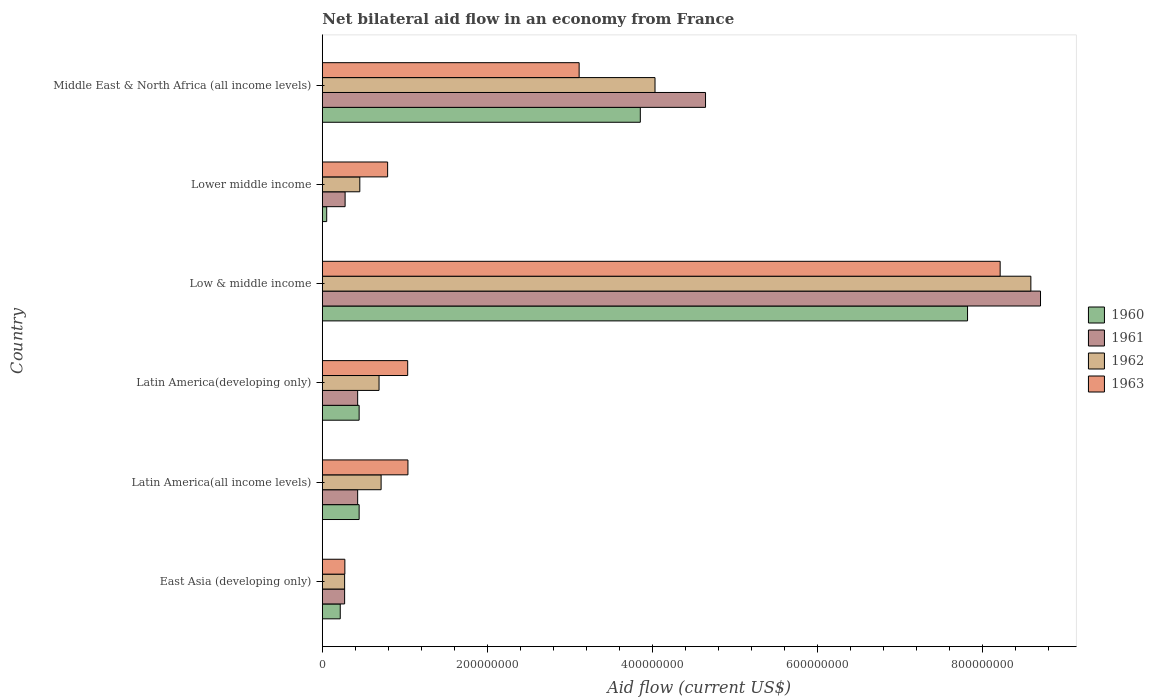Are the number of bars per tick equal to the number of legend labels?
Make the answer very short. Yes. Are the number of bars on each tick of the Y-axis equal?
Ensure brevity in your answer.  Yes. How many bars are there on the 3rd tick from the top?
Offer a terse response. 4. What is the label of the 4th group of bars from the top?
Your answer should be compact. Latin America(developing only). In how many cases, is the number of bars for a given country not equal to the number of legend labels?
Ensure brevity in your answer.  0. What is the net bilateral aid flow in 1961 in Lower middle income?
Keep it short and to the point. 2.76e+07. Across all countries, what is the maximum net bilateral aid flow in 1963?
Keep it short and to the point. 8.21e+08. Across all countries, what is the minimum net bilateral aid flow in 1961?
Make the answer very short. 2.70e+07. In which country was the net bilateral aid flow in 1963 minimum?
Offer a very short reply. East Asia (developing only). What is the total net bilateral aid flow in 1961 in the graph?
Ensure brevity in your answer.  1.47e+09. What is the difference between the net bilateral aid flow in 1961 in East Asia (developing only) and that in Latin America(developing only)?
Your answer should be compact. -1.58e+07. What is the difference between the net bilateral aid flow in 1962 in Middle East & North Africa (all income levels) and the net bilateral aid flow in 1961 in Lower middle income?
Keep it short and to the point. 3.75e+08. What is the average net bilateral aid flow in 1962 per country?
Keep it short and to the point. 2.46e+08. What is the difference between the net bilateral aid flow in 1961 and net bilateral aid flow in 1960 in Middle East & North Africa (all income levels)?
Offer a very short reply. 7.90e+07. What is the ratio of the net bilateral aid flow in 1962 in Latin America(all income levels) to that in Latin America(developing only)?
Provide a short and direct response. 1.04. Is the net bilateral aid flow in 1960 in Lower middle income less than that in Middle East & North Africa (all income levels)?
Ensure brevity in your answer.  Yes. What is the difference between the highest and the second highest net bilateral aid flow in 1962?
Keep it short and to the point. 4.55e+08. What is the difference between the highest and the lowest net bilateral aid flow in 1961?
Offer a terse response. 8.43e+08. Is the sum of the net bilateral aid flow in 1963 in East Asia (developing only) and Latin America(developing only) greater than the maximum net bilateral aid flow in 1961 across all countries?
Ensure brevity in your answer.  No. What does the 2nd bar from the top in Low & middle income represents?
Your answer should be very brief. 1962. What does the 4th bar from the bottom in East Asia (developing only) represents?
Make the answer very short. 1963. How many bars are there?
Make the answer very short. 24. What is the difference between two consecutive major ticks on the X-axis?
Provide a short and direct response. 2.00e+08. Are the values on the major ticks of X-axis written in scientific E-notation?
Your response must be concise. No. Does the graph contain grids?
Your answer should be very brief. No. How are the legend labels stacked?
Provide a short and direct response. Vertical. What is the title of the graph?
Give a very brief answer. Net bilateral aid flow in an economy from France. Does "1967" appear as one of the legend labels in the graph?
Your response must be concise. No. What is the label or title of the X-axis?
Your answer should be compact. Aid flow (current US$). What is the label or title of the Y-axis?
Make the answer very short. Country. What is the Aid flow (current US$) of 1960 in East Asia (developing only)?
Your response must be concise. 2.17e+07. What is the Aid flow (current US$) of 1961 in East Asia (developing only)?
Your response must be concise. 2.70e+07. What is the Aid flow (current US$) in 1962 in East Asia (developing only)?
Your response must be concise. 2.70e+07. What is the Aid flow (current US$) of 1963 in East Asia (developing only)?
Your response must be concise. 2.73e+07. What is the Aid flow (current US$) in 1960 in Latin America(all income levels)?
Keep it short and to the point. 4.46e+07. What is the Aid flow (current US$) of 1961 in Latin America(all income levels)?
Offer a terse response. 4.28e+07. What is the Aid flow (current US$) in 1962 in Latin America(all income levels)?
Provide a succinct answer. 7.12e+07. What is the Aid flow (current US$) of 1963 in Latin America(all income levels)?
Ensure brevity in your answer.  1.04e+08. What is the Aid flow (current US$) in 1960 in Latin America(developing only)?
Give a very brief answer. 4.46e+07. What is the Aid flow (current US$) of 1961 in Latin America(developing only)?
Make the answer very short. 4.28e+07. What is the Aid flow (current US$) of 1962 in Latin America(developing only)?
Your answer should be compact. 6.87e+07. What is the Aid flow (current US$) in 1963 in Latin America(developing only)?
Give a very brief answer. 1.03e+08. What is the Aid flow (current US$) of 1960 in Low & middle income?
Your answer should be compact. 7.82e+08. What is the Aid flow (current US$) in 1961 in Low & middle income?
Offer a terse response. 8.70e+08. What is the Aid flow (current US$) of 1962 in Low & middle income?
Ensure brevity in your answer.  8.58e+08. What is the Aid flow (current US$) in 1963 in Low & middle income?
Provide a succinct answer. 8.21e+08. What is the Aid flow (current US$) of 1960 in Lower middle income?
Keep it short and to the point. 5.30e+06. What is the Aid flow (current US$) in 1961 in Lower middle income?
Your answer should be very brief. 2.76e+07. What is the Aid flow (current US$) in 1962 in Lower middle income?
Offer a very short reply. 4.54e+07. What is the Aid flow (current US$) of 1963 in Lower middle income?
Provide a succinct answer. 7.91e+07. What is the Aid flow (current US$) of 1960 in Middle East & North Africa (all income levels)?
Make the answer very short. 3.85e+08. What is the Aid flow (current US$) of 1961 in Middle East & North Africa (all income levels)?
Make the answer very short. 4.64e+08. What is the Aid flow (current US$) of 1962 in Middle East & North Africa (all income levels)?
Keep it short and to the point. 4.03e+08. What is the Aid flow (current US$) in 1963 in Middle East & North Africa (all income levels)?
Provide a succinct answer. 3.11e+08. Across all countries, what is the maximum Aid flow (current US$) of 1960?
Your answer should be compact. 7.82e+08. Across all countries, what is the maximum Aid flow (current US$) in 1961?
Provide a short and direct response. 8.70e+08. Across all countries, what is the maximum Aid flow (current US$) in 1962?
Offer a very short reply. 8.58e+08. Across all countries, what is the maximum Aid flow (current US$) of 1963?
Provide a succinct answer. 8.21e+08. Across all countries, what is the minimum Aid flow (current US$) of 1960?
Your response must be concise. 5.30e+06. Across all countries, what is the minimum Aid flow (current US$) of 1961?
Your answer should be very brief. 2.70e+07. Across all countries, what is the minimum Aid flow (current US$) in 1962?
Keep it short and to the point. 2.70e+07. Across all countries, what is the minimum Aid flow (current US$) of 1963?
Make the answer very short. 2.73e+07. What is the total Aid flow (current US$) in 1960 in the graph?
Ensure brevity in your answer.  1.28e+09. What is the total Aid flow (current US$) in 1961 in the graph?
Make the answer very short. 1.47e+09. What is the total Aid flow (current US$) of 1962 in the graph?
Make the answer very short. 1.47e+09. What is the total Aid flow (current US$) of 1963 in the graph?
Ensure brevity in your answer.  1.45e+09. What is the difference between the Aid flow (current US$) in 1960 in East Asia (developing only) and that in Latin America(all income levels)?
Offer a terse response. -2.29e+07. What is the difference between the Aid flow (current US$) of 1961 in East Asia (developing only) and that in Latin America(all income levels)?
Provide a short and direct response. -1.58e+07. What is the difference between the Aid flow (current US$) in 1962 in East Asia (developing only) and that in Latin America(all income levels)?
Provide a succinct answer. -4.42e+07. What is the difference between the Aid flow (current US$) of 1963 in East Asia (developing only) and that in Latin America(all income levels)?
Your answer should be very brief. -7.64e+07. What is the difference between the Aid flow (current US$) of 1960 in East Asia (developing only) and that in Latin America(developing only)?
Give a very brief answer. -2.29e+07. What is the difference between the Aid flow (current US$) in 1961 in East Asia (developing only) and that in Latin America(developing only)?
Offer a very short reply. -1.58e+07. What is the difference between the Aid flow (current US$) of 1962 in East Asia (developing only) and that in Latin America(developing only)?
Offer a very short reply. -4.17e+07. What is the difference between the Aid flow (current US$) of 1963 in East Asia (developing only) and that in Latin America(developing only)?
Provide a succinct answer. -7.61e+07. What is the difference between the Aid flow (current US$) of 1960 in East Asia (developing only) and that in Low & middle income?
Give a very brief answer. -7.60e+08. What is the difference between the Aid flow (current US$) in 1961 in East Asia (developing only) and that in Low & middle income?
Provide a short and direct response. -8.43e+08. What is the difference between the Aid flow (current US$) in 1962 in East Asia (developing only) and that in Low & middle income?
Offer a very short reply. -8.31e+08. What is the difference between the Aid flow (current US$) of 1963 in East Asia (developing only) and that in Low & middle income?
Your answer should be very brief. -7.94e+08. What is the difference between the Aid flow (current US$) of 1960 in East Asia (developing only) and that in Lower middle income?
Provide a succinct answer. 1.64e+07. What is the difference between the Aid flow (current US$) in 1961 in East Asia (developing only) and that in Lower middle income?
Offer a terse response. -6.00e+05. What is the difference between the Aid flow (current US$) in 1962 in East Asia (developing only) and that in Lower middle income?
Ensure brevity in your answer.  -1.84e+07. What is the difference between the Aid flow (current US$) of 1963 in East Asia (developing only) and that in Lower middle income?
Keep it short and to the point. -5.18e+07. What is the difference between the Aid flow (current US$) of 1960 in East Asia (developing only) and that in Middle East & North Africa (all income levels)?
Offer a very short reply. -3.64e+08. What is the difference between the Aid flow (current US$) of 1961 in East Asia (developing only) and that in Middle East & North Africa (all income levels)?
Keep it short and to the point. -4.37e+08. What is the difference between the Aid flow (current US$) of 1962 in East Asia (developing only) and that in Middle East & North Africa (all income levels)?
Ensure brevity in your answer.  -3.76e+08. What is the difference between the Aid flow (current US$) of 1963 in East Asia (developing only) and that in Middle East & North Africa (all income levels)?
Offer a terse response. -2.84e+08. What is the difference between the Aid flow (current US$) of 1962 in Latin America(all income levels) and that in Latin America(developing only)?
Offer a very short reply. 2.50e+06. What is the difference between the Aid flow (current US$) of 1963 in Latin America(all income levels) and that in Latin America(developing only)?
Ensure brevity in your answer.  3.00e+05. What is the difference between the Aid flow (current US$) of 1960 in Latin America(all income levels) and that in Low & middle income?
Your answer should be very brief. -7.37e+08. What is the difference between the Aid flow (current US$) of 1961 in Latin America(all income levels) and that in Low & middle income?
Your answer should be compact. -8.27e+08. What is the difference between the Aid flow (current US$) of 1962 in Latin America(all income levels) and that in Low & middle income?
Give a very brief answer. -7.87e+08. What is the difference between the Aid flow (current US$) of 1963 in Latin America(all income levels) and that in Low & middle income?
Offer a very short reply. -7.17e+08. What is the difference between the Aid flow (current US$) in 1960 in Latin America(all income levels) and that in Lower middle income?
Provide a succinct answer. 3.93e+07. What is the difference between the Aid flow (current US$) in 1961 in Latin America(all income levels) and that in Lower middle income?
Give a very brief answer. 1.52e+07. What is the difference between the Aid flow (current US$) in 1962 in Latin America(all income levels) and that in Lower middle income?
Keep it short and to the point. 2.58e+07. What is the difference between the Aid flow (current US$) of 1963 in Latin America(all income levels) and that in Lower middle income?
Ensure brevity in your answer.  2.46e+07. What is the difference between the Aid flow (current US$) in 1960 in Latin America(all income levels) and that in Middle East & North Africa (all income levels)?
Provide a succinct answer. -3.41e+08. What is the difference between the Aid flow (current US$) in 1961 in Latin America(all income levels) and that in Middle East & North Africa (all income levels)?
Your answer should be compact. -4.21e+08. What is the difference between the Aid flow (current US$) of 1962 in Latin America(all income levels) and that in Middle East & North Africa (all income levels)?
Your answer should be very brief. -3.32e+08. What is the difference between the Aid flow (current US$) in 1963 in Latin America(all income levels) and that in Middle East & North Africa (all income levels)?
Keep it short and to the point. -2.07e+08. What is the difference between the Aid flow (current US$) of 1960 in Latin America(developing only) and that in Low & middle income?
Provide a short and direct response. -7.37e+08. What is the difference between the Aid flow (current US$) of 1961 in Latin America(developing only) and that in Low & middle income?
Make the answer very short. -8.27e+08. What is the difference between the Aid flow (current US$) in 1962 in Latin America(developing only) and that in Low & middle income?
Your response must be concise. -7.90e+08. What is the difference between the Aid flow (current US$) of 1963 in Latin America(developing only) and that in Low & middle income?
Offer a very short reply. -7.18e+08. What is the difference between the Aid flow (current US$) of 1960 in Latin America(developing only) and that in Lower middle income?
Give a very brief answer. 3.93e+07. What is the difference between the Aid flow (current US$) of 1961 in Latin America(developing only) and that in Lower middle income?
Offer a terse response. 1.52e+07. What is the difference between the Aid flow (current US$) of 1962 in Latin America(developing only) and that in Lower middle income?
Your response must be concise. 2.33e+07. What is the difference between the Aid flow (current US$) in 1963 in Latin America(developing only) and that in Lower middle income?
Offer a very short reply. 2.43e+07. What is the difference between the Aid flow (current US$) in 1960 in Latin America(developing only) and that in Middle East & North Africa (all income levels)?
Offer a very short reply. -3.41e+08. What is the difference between the Aid flow (current US$) in 1961 in Latin America(developing only) and that in Middle East & North Africa (all income levels)?
Your response must be concise. -4.21e+08. What is the difference between the Aid flow (current US$) in 1962 in Latin America(developing only) and that in Middle East & North Africa (all income levels)?
Provide a succinct answer. -3.34e+08. What is the difference between the Aid flow (current US$) of 1963 in Latin America(developing only) and that in Middle East & North Africa (all income levels)?
Ensure brevity in your answer.  -2.08e+08. What is the difference between the Aid flow (current US$) in 1960 in Low & middle income and that in Lower middle income?
Your response must be concise. 7.76e+08. What is the difference between the Aid flow (current US$) in 1961 in Low & middle income and that in Lower middle income?
Your answer should be compact. 8.42e+08. What is the difference between the Aid flow (current US$) of 1962 in Low & middle income and that in Lower middle income?
Offer a very short reply. 8.13e+08. What is the difference between the Aid flow (current US$) of 1963 in Low & middle income and that in Lower middle income?
Keep it short and to the point. 7.42e+08. What is the difference between the Aid flow (current US$) of 1960 in Low & middle income and that in Middle East & North Africa (all income levels)?
Keep it short and to the point. 3.96e+08. What is the difference between the Aid flow (current US$) of 1961 in Low & middle income and that in Middle East & North Africa (all income levels)?
Keep it short and to the point. 4.06e+08. What is the difference between the Aid flow (current US$) in 1962 in Low & middle income and that in Middle East & North Africa (all income levels)?
Make the answer very short. 4.55e+08. What is the difference between the Aid flow (current US$) in 1963 in Low & middle income and that in Middle East & North Africa (all income levels)?
Give a very brief answer. 5.10e+08. What is the difference between the Aid flow (current US$) of 1960 in Lower middle income and that in Middle East & North Africa (all income levels)?
Give a very brief answer. -3.80e+08. What is the difference between the Aid flow (current US$) in 1961 in Lower middle income and that in Middle East & North Africa (all income levels)?
Provide a succinct answer. -4.37e+08. What is the difference between the Aid flow (current US$) of 1962 in Lower middle income and that in Middle East & North Africa (all income levels)?
Keep it short and to the point. -3.58e+08. What is the difference between the Aid flow (current US$) of 1963 in Lower middle income and that in Middle East & North Africa (all income levels)?
Offer a terse response. -2.32e+08. What is the difference between the Aid flow (current US$) in 1960 in East Asia (developing only) and the Aid flow (current US$) in 1961 in Latin America(all income levels)?
Your answer should be very brief. -2.11e+07. What is the difference between the Aid flow (current US$) in 1960 in East Asia (developing only) and the Aid flow (current US$) in 1962 in Latin America(all income levels)?
Give a very brief answer. -4.95e+07. What is the difference between the Aid flow (current US$) in 1960 in East Asia (developing only) and the Aid flow (current US$) in 1963 in Latin America(all income levels)?
Provide a short and direct response. -8.20e+07. What is the difference between the Aid flow (current US$) of 1961 in East Asia (developing only) and the Aid flow (current US$) of 1962 in Latin America(all income levels)?
Ensure brevity in your answer.  -4.42e+07. What is the difference between the Aid flow (current US$) in 1961 in East Asia (developing only) and the Aid flow (current US$) in 1963 in Latin America(all income levels)?
Give a very brief answer. -7.67e+07. What is the difference between the Aid flow (current US$) in 1962 in East Asia (developing only) and the Aid flow (current US$) in 1963 in Latin America(all income levels)?
Make the answer very short. -7.67e+07. What is the difference between the Aid flow (current US$) in 1960 in East Asia (developing only) and the Aid flow (current US$) in 1961 in Latin America(developing only)?
Your response must be concise. -2.11e+07. What is the difference between the Aid flow (current US$) in 1960 in East Asia (developing only) and the Aid flow (current US$) in 1962 in Latin America(developing only)?
Provide a short and direct response. -4.70e+07. What is the difference between the Aid flow (current US$) in 1960 in East Asia (developing only) and the Aid flow (current US$) in 1963 in Latin America(developing only)?
Your answer should be compact. -8.17e+07. What is the difference between the Aid flow (current US$) of 1961 in East Asia (developing only) and the Aid flow (current US$) of 1962 in Latin America(developing only)?
Offer a terse response. -4.17e+07. What is the difference between the Aid flow (current US$) of 1961 in East Asia (developing only) and the Aid flow (current US$) of 1963 in Latin America(developing only)?
Your response must be concise. -7.64e+07. What is the difference between the Aid flow (current US$) of 1962 in East Asia (developing only) and the Aid flow (current US$) of 1963 in Latin America(developing only)?
Ensure brevity in your answer.  -7.64e+07. What is the difference between the Aid flow (current US$) in 1960 in East Asia (developing only) and the Aid flow (current US$) in 1961 in Low & middle income?
Provide a short and direct response. -8.48e+08. What is the difference between the Aid flow (current US$) in 1960 in East Asia (developing only) and the Aid flow (current US$) in 1962 in Low & middle income?
Your answer should be very brief. -8.37e+08. What is the difference between the Aid flow (current US$) of 1960 in East Asia (developing only) and the Aid flow (current US$) of 1963 in Low & middle income?
Offer a very short reply. -7.99e+08. What is the difference between the Aid flow (current US$) of 1961 in East Asia (developing only) and the Aid flow (current US$) of 1962 in Low & middle income?
Offer a very short reply. -8.31e+08. What is the difference between the Aid flow (current US$) of 1961 in East Asia (developing only) and the Aid flow (current US$) of 1963 in Low & middle income?
Ensure brevity in your answer.  -7.94e+08. What is the difference between the Aid flow (current US$) of 1962 in East Asia (developing only) and the Aid flow (current US$) of 1963 in Low & middle income?
Keep it short and to the point. -7.94e+08. What is the difference between the Aid flow (current US$) of 1960 in East Asia (developing only) and the Aid flow (current US$) of 1961 in Lower middle income?
Offer a very short reply. -5.90e+06. What is the difference between the Aid flow (current US$) of 1960 in East Asia (developing only) and the Aid flow (current US$) of 1962 in Lower middle income?
Your response must be concise. -2.37e+07. What is the difference between the Aid flow (current US$) of 1960 in East Asia (developing only) and the Aid flow (current US$) of 1963 in Lower middle income?
Keep it short and to the point. -5.74e+07. What is the difference between the Aid flow (current US$) of 1961 in East Asia (developing only) and the Aid flow (current US$) of 1962 in Lower middle income?
Your answer should be very brief. -1.84e+07. What is the difference between the Aid flow (current US$) of 1961 in East Asia (developing only) and the Aid flow (current US$) of 1963 in Lower middle income?
Provide a succinct answer. -5.21e+07. What is the difference between the Aid flow (current US$) in 1962 in East Asia (developing only) and the Aid flow (current US$) in 1963 in Lower middle income?
Provide a short and direct response. -5.21e+07. What is the difference between the Aid flow (current US$) of 1960 in East Asia (developing only) and the Aid flow (current US$) of 1961 in Middle East & North Africa (all income levels)?
Give a very brief answer. -4.42e+08. What is the difference between the Aid flow (current US$) in 1960 in East Asia (developing only) and the Aid flow (current US$) in 1962 in Middle East & North Africa (all income levels)?
Offer a terse response. -3.81e+08. What is the difference between the Aid flow (current US$) of 1960 in East Asia (developing only) and the Aid flow (current US$) of 1963 in Middle East & North Africa (all income levels)?
Make the answer very short. -2.89e+08. What is the difference between the Aid flow (current US$) of 1961 in East Asia (developing only) and the Aid flow (current US$) of 1962 in Middle East & North Africa (all income levels)?
Provide a short and direct response. -3.76e+08. What is the difference between the Aid flow (current US$) in 1961 in East Asia (developing only) and the Aid flow (current US$) in 1963 in Middle East & North Africa (all income levels)?
Your answer should be compact. -2.84e+08. What is the difference between the Aid flow (current US$) of 1962 in East Asia (developing only) and the Aid flow (current US$) of 1963 in Middle East & North Africa (all income levels)?
Offer a terse response. -2.84e+08. What is the difference between the Aid flow (current US$) of 1960 in Latin America(all income levels) and the Aid flow (current US$) of 1961 in Latin America(developing only)?
Offer a very short reply. 1.80e+06. What is the difference between the Aid flow (current US$) of 1960 in Latin America(all income levels) and the Aid flow (current US$) of 1962 in Latin America(developing only)?
Give a very brief answer. -2.41e+07. What is the difference between the Aid flow (current US$) in 1960 in Latin America(all income levels) and the Aid flow (current US$) in 1963 in Latin America(developing only)?
Your answer should be compact. -5.88e+07. What is the difference between the Aid flow (current US$) of 1961 in Latin America(all income levels) and the Aid flow (current US$) of 1962 in Latin America(developing only)?
Your answer should be compact. -2.59e+07. What is the difference between the Aid flow (current US$) in 1961 in Latin America(all income levels) and the Aid flow (current US$) in 1963 in Latin America(developing only)?
Offer a very short reply. -6.06e+07. What is the difference between the Aid flow (current US$) of 1962 in Latin America(all income levels) and the Aid flow (current US$) of 1963 in Latin America(developing only)?
Offer a very short reply. -3.22e+07. What is the difference between the Aid flow (current US$) in 1960 in Latin America(all income levels) and the Aid flow (current US$) in 1961 in Low & middle income?
Offer a very short reply. -8.25e+08. What is the difference between the Aid flow (current US$) of 1960 in Latin America(all income levels) and the Aid flow (current US$) of 1962 in Low & middle income?
Offer a terse response. -8.14e+08. What is the difference between the Aid flow (current US$) of 1960 in Latin America(all income levels) and the Aid flow (current US$) of 1963 in Low & middle income?
Your answer should be compact. -7.76e+08. What is the difference between the Aid flow (current US$) in 1961 in Latin America(all income levels) and the Aid flow (current US$) in 1962 in Low & middle income?
Offer a terse response. -8.16e+08. What is the difference between the Aid flow (current US$) of 1961 in Latin America(all income levels) and the Aid flow (current US$) of 1963 in Low & middle income?
Keep it short and to the point. -7.78e+08. What is the difference between the Aid flow (current US$) of 1962 in Latin America(all income levels) and the Aid flow (current US$) of 1963 in Low & middle income?
Offer a very short reply. -7.50e+08. What is the difference between the Aid flow (current US$) of 1960 in Latin America(all income levels) and the Aid flow (current US$) of 1961 in Lower middle income?
Offer a very short reply. 1.70e+07. What is the difference between the Aid flow (current US$) of 1960 in Latin America(all income levels) and the Aid flow (current US$) of 1962 in Lower middle income?
Your answer should be very brief. -8.00e+05. What is the difference between the Aid flow (current US$) of 1960 in Latin America(all income levels) and the Aid flow (current US$) of 1963 in Lower middle income?
Make the answer very short. -3.45e+07. What is the difference between the Aid flow (current US$) in 1961 in Latin America(all income levels) and the Aid flow (current US$) in 1962 in Lower middle income?
Give a very brief answer. -2.60e+06. What is the difference between the Aid flow (current US$) in 1961 in Latin America(all income levels) and the Aid flow (current US$) in 1963 in Lower middle income?
Your answer should be very brief. -3.63e+07. What is the difference between the Aid flow (current US$) of 1962 in Latin America(all income levels) and the Aid flow (current US$) of 1963 in Lower middle income?
Your answer should be very brief. -7.90e+06. What is the difference between the Aid flow (current US$) of 1960 in Latin America(all income levels) and the Aid flow (current US$) of 1961 in Middle East & North Africa (all income levels)?
Offer a very short reply. -4.20e+08. What is the difference between the Aid flow (current US$) in 1960 in Latin America(all income levels) and the Aid flow (current US$) in 1962 in Middle East & North Africa (all income levels)?
Provide a succinct answer. -3.58e+08. What is the difference between the Aid flow (current US$) of 1960 in Latin America(all income levels) and the Aid flow (current US$) of 1963 in Middle East & North Africa (all income levels)?
Give a very brief answer. -2.66e+08. What is the difference between the Aid flow (current US$) in 1961 in Latin America(all income levels) and the Aid flow (current US$) in 1962 in Middle East & North Africa (all income levels)?
Provide a succinct answer. -3.60e+08. What is the difference between the Aid flow (current US$) in 1961 in Latin America(all income levels) and the Aid flow (current US$) in 1963 in Middle East & North Africa (all income levels)?
Provide a succinct answer. -2.68e+08. What is the difference between the Aid flow (current US$) in 1962 in Latin America(all income levels) and the Aid flow (current US$) in 1963 in Middle East & North Africa (all income levels)?
Your response must be concise. -2.40e+08. What is the difference between the Aid flow (current US$) in 1960 in Latin America(developing only) and the Aid flow (current US$) in 1961 in Low & middle income?
Give a very brief answer. -8.25e+08. What is the difference between the Aid flow (current US$) in 1960 in Latin America(developing only) and the Aid flow (current US$) in 1962 in Low & middle income?
Make the answer very short. -8.14e+08. What is the difference between the Aid flow (current US$) in 1960 in Latin America(developing only) and the Aid flow (current US$) in 1963 in Low & middle income?
Your answer should be very brief. -7.76e+08. What is the difference between the Aid flow (current US$) of 1961 in Latin America(developing only) and the Aid flow (current US$) of 1962 in Low & middle income?
Your answer should be compact. -8.16e+08. What is the difference between the Aid flow (current US$) in 1961 in Latin America(developing only) and the Aid flow (current US$) in 1963 in Low & middle income?
Your answer should be compact. -7.78e+08. What is the difference between the Aid flow (current US$) of 1962 in Latin America(developing only) and the Aid flow (current US$) of 1963 in Low & middle income?
Your response must be concise. -7.52e+08. What is the difference between the Aid flow (current US$) in 1960 in Latin America(developing only) and the Aid flow (current US$) in 1961 in Lower middle income?
Keep it short and to the point. 1.70e+07. What is the difference between the Aid flow (current US$) in 1960 in Latin America(developing only) and the Aid flow (current US$) in 1962 in Lower middle income?
Your answer should be compact. -8.00e+05. What is the difference between the Aid flow (current US$) in 1960 in Latin America(developing only) and the Aid flow (current US$) in 1963 in Lower middle income?
Make the answer very short. -3.45e+07. What is the difference between the Aid flow (current US$) of 1961 in Latin America(developing only) and the Aid flow (current US$) of 1962 in Lower middle income?
Keep it short and to the point. -2.60e+06. What is the difference between the Aid flow (current US$) in 1961 in Latin America(developing only) and the Aid flow (current US$) in 1963 in Lower middle income?
Your response must be concise. -3.63e+07. What is the difference between the Aid flow (current US$) in 1962 in Latin America(developing only) and the Aid flow (current US$) in 1963 in Lower middle income?
Keep it short and to the point. -1.04e+07. What is the difference between the Aid flow (current US$) in 1960 in Latin America(developing only) and the Aid flow (current US$) in 1961 in Middle East & North Africa (all income levels)?
Ensure brevity in your answer.  -4.20e+08. What is the difference between the Aid flow (current US$) in 1960 in Latin America(developing only) and the Aid flow (current US$) in 1962 in Middle East & North Africa (all income levels)?
Provide a succinct answer. -3.58e+08. What is the difference between the Aid flow (current US$) of 1960 in Latin America(developing only) and the Aid flow (current US$) of 1963 in Middle East & North Africa (all income levels)?
Provide a succinct answer. -2.66e+08. What is the difference between the Aid flow (current US$) of 1961 in Latin America(developing only) and the Aid flow (current US$) of 1962 in Middle East & North Africa (all income levels)?
Your answer should be very brief. -3.60e+08. What is the difference between the Aid flow (current US$) of 1961 in Latin America(developing only) and the Aid flow (current US$) of 1963 in Middle East & North Africa (all income levels)?
Make the answer very short. -2.68e+08. What is the difference between the Aid flow (current US$) in 1962 in Latin America(developing only) and the Aid flow (current US$) in 1963 in Middle East & North Africa (all income levels)?
Your answer should be compact. -2.42e+08. What is the difference between the Aid flow (current US$) in 1960 in Low & middle income and the Aid flow (current US$) in 1961 in Lower middle income?
Offer a very short reply. 7.54e+08. What is the difference between the Aid flow (current US$) of 1960 in Low & middle income and the Aid flow (current US$) of 1962 in Lower middle income?
Offer a terse response. 7.36e+08. What is the difference between the Aid flow (current US$) in 1960 in Low & middle income and the Aid flow (current US$) in 1963 in Lower middle income?
Offer a terse response. 7.02e+08. What is the difference between the Aid flow (current US$) of 1961 in Low & middle income and the Aid flow (current US$) of 1962 in Lower middle income?
Provide a succinct answer. 8.25e+08. What is the difference between the Aid flow (current US$) in 1961 in Low & middle income and the Aid flow (current US$) in 1963 in Lower middle income?
Offer a terse response. 7.91e+08. What is the difference between the Aid flow (current US$) of 1962 in Low & middle income and the Aid flow (current US$) of 1963 in Lower middle income?
Keep it short and to the point. 7.79e+08. What is the difference between the Aid flow (current US$) of 1960 in Low & middle income and the Aid flow (current US$) of 1961 in Middle East & North Africa (all income levels)?
Keep it short and to the point. 3.17e+08. What is the difference between the Aid flow (current US$) in 1960 in Low & middle income and the Aid flow (current US$) in 1962 in Middle East & North Africa (all income levels)?
Provide a short and direct response. 3.79e+08. What is the difference between the Aid flow (current US$) in 1960 in Low & middle income and the Aid flow (current US$) in 1963 in Middle East & North Africa (all income levels)?
Make the answer very short. 4.70e+08. What is the difference between the Aid flow (current US$) of 1961 in Low & middle income and the Aid flow (current US$) of 1962 in Middle East & North Africa (all income levels)?
Make the answer very short. 4.67e+08. What is the difference between the Aid flow (current US$) of 1961 in Low & middle income and the Aid flow (current US$) of 1963 in Middle East & North Africa (all income levels)?
Keep it short and to the point. 5.59e+08. What is the difference between the Aid flow (current US$) in 1962 in Low & middle income and the Aid flow (current US$) in 1963 in Middle East & North Africa (all income levels)?
Make the answer very short. 5.47e+08. What is the difference between the Aid flow (current US$) in 1960 in Lower middle income and the Aid flow (current US$) in 1961 in Middle East & North Africa (all income levels)?
Provide a short and direct response. -4.59e+08. What is the difference between the Aid flow (current US$) in 1960 in Lower middle income and the Aid flow (current US$) in 1962 in Middle East & North Africa (all income levels)?
Your answer should be compact. -3.98e+08. What is the difference between the Aid flow (current US$) of 1960 in Lower middle income and the Aid flow (current US$) of 1963 in Middle East & North Africa (all income levels)?
Your answer should be very brief. -3.06e+08. What is the difference between the Aid flow (current US$) of 1961 in Lower middle income and the Aid flow (current US$) of 1962 in Middle East & North Africa (all income levels)?
Make the answer very short. -3.75e+08. What is the difference between the Aid flow (current US$) in 1961 in Lower middle income and the Aid flow (current US$) in 1963 in Middle East & North Africa (all income levels)?
Give a very brief answer. -2.84e+08. What is the difference between the Aid flow (current US$) of 1962 in Lower middle income and the Aid flow (current US$) of 1963 in Middle East & North Africa (all income levels)?
Give a very brief answer. -2.66e+08. What is the average Aid flow (current US$) in 1960 per country?
Ensure brevity in your answer.  2.14e+08. What is the average Aid flow (current US$) in 1961 per country?
Provide a succinct answer. 2.46e+08. What is the average Aid flow (current US$) in 1962 per country?
Offer a terse response. 2.46e+08. What is the average Aid flow (current US$) of 1963 per country?
Your answer should be compact. 2.41e+08. What is the difference between the Aid flow (current US$) in 1960 and Aid flow (current US$) in 1961 in East Asia (developing only)?
Provide a short and direct response. -5.30e+06. What is the difference between the Aid flow (current US$) of 1960 and Aid flow (current US$) of 1962 in East Asia (developing only)?
Your response must be concise. -5.30e+06. What is the difference between the Aid flow (current US$) of 1960 and Aid flow (current US$) of 1963 in East Asia (developing only)?
Keep it short and to the point. -5.60e+06. What is the difference between the Aid flow (current US$) in 1961 and Aid flow (current US$) in 1962 in East Asia (developing only)?
Keep it short and to the point. 0. What is the difference between the Aid flow (current US$) of 1962 and Aid flow (current US$) of 1963 in East Asia (developing only)?
Provide a succinct answer. -3.00e+05. What is the difference between the Aid flow (current US$) of 1960 and Aid flow (current US$) of 1961 in Latin America(all income levels)?
Provide a succinct answer. 1.80e+06. What is the difference between the Aid flow (current US$) in 1960 and Aid flow (current US$) in 1962 in Latin America(all income levels)?
Your response must be concise. -2.66e+07. What is the difference between the Aid flow (current US$) in 1960 and Aid flow (current US$) in 1963 in Latin America(all income levels)?
Your answer should be very brief. -5.91e+07. What is the difference between the Aid flow (current US$) of 1961 and Aid flow (current US$) of 1962 in Latin America(all income levels)?
Make the answer very short. -2.84e+07. What is the difference between the Aid flow (current US$) of 1961 and Aid flow (current US$) of 1963 in Latin America(all income levels)?
Your answer should be compact. -6.09e+07. What is the difference between the Aid flow (current US$) in 1962 and Aid flow (current US$) in 1963 in Latin America(all income levels)?
Your answer should be very brief. -3.25e+07. What is the difference between the Aid flow (current US$) of 1960 and Aid flow (current US$) of 1961 in Latin America(developing only)?
Give a very brief answer. 1.80e+06. What is the difference between the Aid flow (current US$) in 1960 and Aid flow (current US$) in 1962 in Latin America(developing only)?
Offer a terse response. -2.41e+07. What is the difference between the Aid flow (current US$) in 1960 and Aid flow (current US$) in 1963 in Latin America(developing only)?
Provide a short and direct response. -5.88e+07. What is the difference between the Aid flow (current US$) in 1961 and Aid flow (current US$) in 1962 in Latin America(developing only)?
Your answer should be very brief. -2.59e+07. What is the difference between the Aid flow (current US$) in 1961 and Aid flow (current US$) in 1963 in Latin America(developing only)?
Your response must be concise. -6.06e+07. What is the difference between the Aid flow (current US$) of 1962 and Aid flow (current US$) of 1963 in Latin America(developing only)?
Keep it short and to the point. -3.47e+07. What is the difference between the Aid flow (current US$) of 1960 and Aid flow (current US$) of 1961 in Low & middle income?
Ensure brevity in your answer.  -8.84e+07. What is the difference between the Aid flow (current US$) of 1960 and Aid flow (current US$) of 1962 in Low & middle income?
Provide a short and direct response. -7.67e+07. What is the difference between the Aid flow (current US$) in 1960 and Aid flow (current US$) in 1963 in Low & middle income?
Give a very brief answer. -3.95e+07. What is the difference between the Aid flow (current US$) in 1961 and Aid flow (current US$) in 1962 in Low & middle income?
Make the answer very short. 1.17e+07. What is the difference between the Aid flow (current US$) of 1961 and Aid flow (current US$) of 1963 in Low & middle income?
Ensure brevity in your answer.  4.89e+07. What is the difference between the Aid flow (current US$) in 1962 and Aid flow (current US$) in 1963 in Low & middle income?
Your response must be concise. 3.72e+07. What is the difference between the Aid flow (current US$) of 1960 and Aid flow (current US$) of 1961 in Lower middle income?
Your response must be concise. -2.23e+07. What is the difference between the Aid flow (current US$) in 1960 and Aid flow (current US$) in 1962 in Lower middle income?
Your answer should be compact. -4.01e+07. What is the difference between the Aid flow (current US$) in 1960 and Aid flow (current US$) in 1963 in Lower middle income?
Offer a very short reply. -7.38e+07. What is the difference between the Aid flow (current US$) of 1961 and Aid flow (current US$) of 1962 in Lower middle income?
Provide a succinct answer. -1.78e+07. What is the difference between the Aid flow (current US$) of 1961 and Aid flow (current US$) of 1963 in Lower middle income?
Your answer should be compact. -5.15e+07. What is the difference between the Aid flow (current US$) in 1962 and Aid flow (current US$) in 1963 in Lower middle income?
Keep it short and to the point. -3.37e+07. What is the difference between the Aid flow (current US$) of 1960 and Aid flow (current US$) of 1961 in Middle East & North Africa (all income levels)?
Keep it short and to the point. -7.90e+07. What is the difference between the Aid flow (current US$) of 1960 and Aid flow (current US$) of 1962 in Middle East & North Africa (all income levels)?
Your answer should be compact. -1.78e+07. What is the difference between the Aid flow (current US$) of 1960 and Aid flow (current US$) of 1963 in Middle East & North Africa (all income levels)?
Ensure brevity in your answer.  7.41e+07. What is the difference between the Aid flow (current US$) in 1961 and Aid flow (current US$) in 1962 in Middle East & North Africa (all income levels)?
Keep it short and to the point. 6.12e+07. What is the difference between the Aid flow (current US$) in 1961 and Aid flow (current US$) in 1963 in Middle East & North Africa (all income levels)?
Your answer should be compact. 1.53e+08. What is the difference between the Aid flow (current US$) in 1962 and Aid flow (current US$) in 1963 in Middle East & North Africa (all income levels)?
Ensure brevity in your answer.  9.19e+07. What is the ratio of the Aid flow (current US$) of 1960 in East Asia (developing only) to that in Latin America(all income levels)?
Provide a short and direct response. 0.49. What is the ratio of the Aid flow (current US$) of 1961 in East Asia (developing only) to that in Latin America(all income levels)?
Offer a terse response. 0.63. What is the ratio of the Aid flow (current US$) of 1962 in East Asia (developing only) to that in Latin America(all income levels)?
Provide a succinct answer. 0.38. What is the ratio of the Aid flow (current US$) in 1963 in East Asia (developing only) to that in Latin America(all income levels)?
Offer a terse response. 0.26. What is the ratio of the Aid flow (current US$) in 1960 in East Asia (developing only) to that in Latin America(developing only)?
Your response must be concise. 0.49. What is the ratio of the Aid flow (current US$) of 1961 in East Asia (developing only) to that in Latin America(developing only)?
Your answer should be very brief. 0.63. What is the ratio of the Aid flow (current US$) of 1962 in East Asia (developing only) to that in Latin America(developing only)?
Your response must be concise. 0.39. What is the ratio of the Aid flow (current US$) of 1963 in East Asia (developing only) to that in Latin America(developing only)?
Your answer should be compact. 0.26. What is the ratio of the Aid flow (current US$) in 1960 in East Asia (developing only) to that in Low & middle income?
Your response must be concise. 0.03. What is the ratio of the Aid flow (current US$) in 1961 in East Asia (developing only) to that in Low & middle income?
Make the answer very short. 0.03. What is the ratio of the Aid flow (current US$) of 1962 in East Asia (developing only) to that in Low & middle income?
Offer a very short reply. 0.03. What is the ratio of the Aid flow (current US$) of 1963 in East Asia (developing only) to that in Low & middle income?
Give a very brief answer. 0.03. What is the ratio of the Aid flow (current US$) of 1960 in East Asia (developing only) to that in Lower middle income?
Offer a very short reply. 4.09. What is the ratio of the Aid flow (current US$) of 1961 in East Asia (developing only) to that in Lower middle income?
Offer a terse response. 0.98. What is the ratio of the Aid flow (current US$) in 1962 in East Asia (developing only) to that in Lower middle income?
Give a very brief answer. 0.59. What is the ratio of the Aid flow (current US$) in 1963 in East Asia (developing only) to that in Lower middle income?
Give a very brief answer. 0.35. What is the ratio of the Aid flow (current US$) of 1960 in East Asia (developing only) to that in Middle East & North Africa (all income levels)?
Your answer should be compact. 0.06. What is the ratio of the Aid flow (current US$) of 1961 in East Asia (developing only) to that in Middle East & North Africa (all income levels)?
Keep it short and to the point. 0.06. What is the ratio of the Aid flow (current US$) in 1962 in East Asia (developing only) to that in Middle East & North Africa (all income levels)?
Offer a terse response. 0.07. What is the ratio of the Aid flow (current US$) in 1963 in East Asia (developing only) to that in Middle East & North Africa (all income levels)?
Ensure brevity in your answer.  0.09. What is the ratio of the Aid flow (current US$) in 1962 in Latin America(all income levels) to that in Latin America(developing only)?
Your response must be concise. 1.04. What is the ratio of the Aid flow (current US$) in 1963 in Latin America(all income levels) to that in Latin America(developing only)?
Your response must be concise. 1. What is the ratio of the Aid flow (current US$) of 1960 in Latin America(all income levels) to that in Low & middle income?
Keep it short and to the point. 0.06. What is the ratio of the Aid flow (current US$) in 1961 in Latin America(all income levels) to that in Low & middle income?
Give a very brief answer. 0.05. What is the ratio of the Aid flow (current US$) in 1962 in Latin America(all income levels) to that in Low & middle income?
Give a very brief answer. 0.08. What is the ratio of the Aid flow (current US$) in 1963 in Latin America(all income levels) to that in Low & middle income?
Your response must be concise. 0.13. What is the ratio of the Aid flow (current US$) in 1960 in Latin America(all income levels) to that in Lower middle income?
Your answer should be compact. 8.42. What is the ratio of the Aid flow (current US$) in 1961 in Latin America(all income levels) to that in Lower middle income?
Offer a terse response. 1.55. What is the ratio of the Aid flow (current US$) of 1962 in Latin America(all income levels) to that in Lower middle income?
Your response must be concise. 1.57. What is the ratio of the Aid flow (current US$) in 1963 in Latin America(all income levels) to that in Lower middle income?
Offer a terse response. 1.31. What is the ratio of the Aid flow (current US$) of 1960 in Latin America(all income levels) to that in Middle East & North Africa (all income levels)?
Your response must be concise. 0.12. What is the ratio of the Aid flow (current US$) of 1961 in Latin America(all income levels) to that in Middle East & North Africa (all income levels)?
Your answer should be compact. 0.09. What is the ratio of the Aid flow (current US$) of 1962 in Latin America(all income levels) to that in Middle East & North Africa (all income levels)?
Make the answer very short. 0.18. What is the ratio of the Aid flow (current US$) in 1963 in Latin America(all income levels) to that in Middle East & North Africa (all income levels)?
Provide a succinct answer. 0.33. What is the ratio of the Aid flow (current US$) of 1960 in Latin America(developing only) to that in Low & middle income?
Your answer should be very brief. 0.06. What is the ratio of the Aid flow (current US$) in 1961 in Latin America(developing only) to that in Low & middle income?
Make the answer very short. 0.05. What is the ratio of the Aid flow (current US$) in 1963 in Latin America(developing only) to that in Low & middle income?
Ensure brevity in your answer.  0.13. What is the ratio of the Aid flow (current US$) in 1960 in Latin America(developing only) to that in Lower middle income?
Keep it short and to the point. 8.42. What is the ratio of the Aid flow (current US$) of 1961 in Latin America(developing only) to that in Lower middle income?
Give a very brief answer. 1.55. What is the ratio of the Aid flow (current US$) of 1962 in Latin America(developing only) to that in Lower middle income?
Make the answer very short. 1.51. What is the ratio of the Aid flow (current US$) in 1963 in Latin America(developing only) to that in Lower middle income?
Keep it short and to the point. 1.31. What is the ratio of the Aid flow (current US$) of 1960 in Latin America(developing only) to that in Middle East & North Africa (all income levels)?
Your answer should be very brief. 0.12. What is the ratio of the Aid flow (current US$) of 1961 in Latin America(developing only) to that in Middle East & North Africa (all income levels)?
Offer a very short reply. 0.09. What is the ratio of the Aid flow (current US$) of 1962 in Latin America(developing only) to that in Middle East & North Africa (all income levels)?
Provide a short and direct response. 0.17. What is the ratio of the Aid flow (current US$) in 1963 in Latin America(developing only) to that in Middle East & North Africa (all income levels)?
Offer a terse response. 0.33. What is the ratio of the Aid flow (current US$) in 1960 in Low & middle income to that in Lower middle income?
Provide a succinct answer. 147.47. What is the ratio of the Aid flow (current US$) of 1961 in Low & middle income to that in Lower middle income?
Provide a short and direct response. 31.52. What is the ratio of the Aid flow (current US$) of 1962 in Low & middle income to that in Lower middle income?
Your answer should be very brief. 18.91. What is the ratio of the Aid flow (current US$) in 1963 in Low & middle income to that in Lower middle income?
Offer a very short reply. 10.38. What is the ratio of the Aid flow (current US$) of 1960 in Low & middle income to that in Middle East & North Africa (all income levels)?
Keep it short and to the point. 2.03. What is the ratio of the Aid flow (current US$) of 1961 in Low & middle income to that in Middle East & North Africa (all income levels)?
Make the answer very short. 1.87. What is the ratio of the Aid flow (current US$) in 1962 in Low & middle income to that in Middle East & North Africa (all income levels)?
Offer a terse response. 2.13. What is the ratio of the Aid flow (current US$) of 1963 in Low & middle income to that in Middle East & North Africa (all income levels)?
Your answer should be compact. 2.64. What is the ratio of the Aid flow (current US$) in 1960 in Lower middle income to that in Middle East & North Africa (all income levels)?
Your answer should be very brief. 0.01. What is the ratio of the Aid flow (current US$) in 1961 in Lower middle income to that in Middle East & North Africa (all income levels)?
Provide a succinct answer. 0.06. What is the ratio of the Aid flow (current US$) in 1962 in Lower middle income to that in Middle East & North Africa (all income levels)?
Your answer should be very brief. 0.11. What is the ratio of the Aid flow (current US$) of 1963 in Lower middle income to that in Middle East & North Africa (all income levels)?
Provide a short and direct response. 0.25. What is the difference between the highest and the second highest Aid flow (current US$) in 1960?
Your answer should be compact. 3.96e+08. What is the difference between the highest and the second highest Aid flow (current US$) in 1961?
Keep it short and to the point. 4.06e+08. What is the difference between the highest and the second highest Aid flow (current US$) in 1962?
Make the answer very short. 4.55e+08. What is the difference between the highest and the second highest Aid flow (current US$) in 1963?
Provide a short and direct response. 5.10e+08. What is the difference between the highest and the lowest Aid flow (current US$) of 1960?
Your response must be concise. 7.76e+08. What is the difference between the highest and the lowest Aid flow (current US$) of 1961?
Your response must be concise. 8.43e+08. What is the difference between the highest and the lowest Aid flow (current US$) of 1962?
Ensure brevity in your answer.  8.31e+08. What is the difference between the highest and the lowest Aid flow (current US$) in 1963?
Provide a succinct answer. 7.94e+08. 